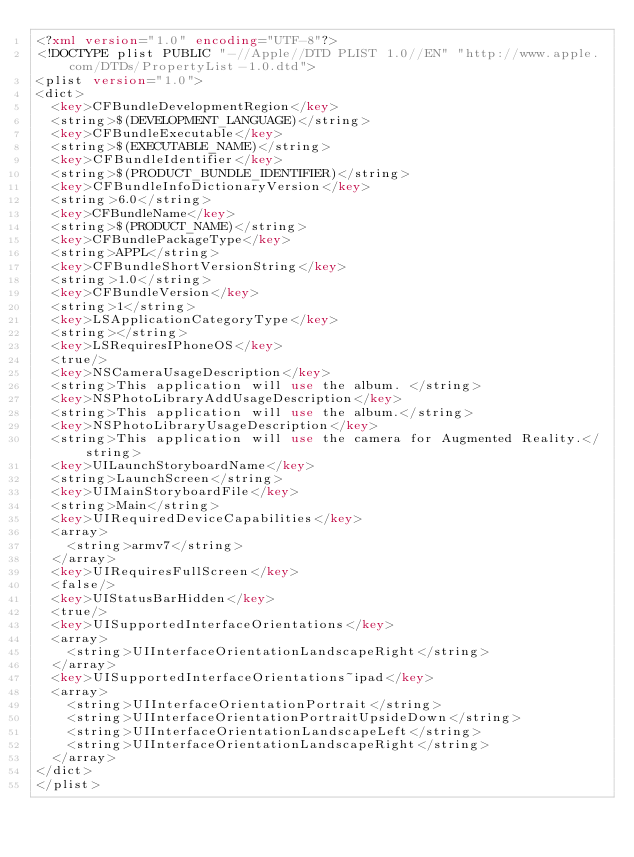<code> <loc_0><loc_0><loc_500><loc_500><_XML_><?xml version="1.0" encoding="UTF-8"?>
<!DOCTYPE plist PUBLIC "-//Apple//DTD PLIST 1.0//EN" "http://www.apple.com/DTDs/PropertyList-1.0.dtd">
<plist version="1.0">
<dict>
	<key>CFBundleDevelopmentRegion</key>
	<string>$(DEVELOPMENT_LANGUAGE)</string>
	<key>CFBundleExecutable</key>
	<string>$(EXECUTABLE_NAME)</string>
	<key>CFBundleIdentifier</key>
	<string>$(PRODUCT_BUNDLE_IDENTIFIER)</string>
	<key>CFBundleInfoDictionaryVersion</key>
	<string>6.0</string>
	<key>CFBundleName</key>
	<string>$(PRODUCT_NAME)</string>
	<key>CFBundlePackageType</key>
	<string>APPL</string>
	<key>CFBundleShortVersionString</key>
	<string>1.0</string>
	<key>CFBundleVersion</key>
	<string>1</string>
	<key>LSApplicationCategoryType</key>
	<string></string>
	<key>LSRequiresIPhoneOS</key>
	<true/>
	<key>NSCameraUsageDescription</key>
	<string>This application will use the album. </string>
	<key>NSPhotoLibraryAddUsageDescription</key>
	<string>This application will use the album.</string>
	<key>NSPhotoLibraryUsageDescription</key>
	<string>This application will use the camera for Augmented Reality.</string>
	<key>UILaunchStoryboardName</key>
	<string>LaunchScreen</string>
	<key>UIMainStoryboardFile</key>
	<string>Main</string>
	<key>UIRequiredDeviceCapabilities</key>
	<array>
		<string>armv7</string>
	</array>
	<key>UIRequiresFullScreen</key>
	<false/>
	<key>UIStatusBarHidden</key>
	<true/>
	<key>UISupportedInterfaceOrientations</key>
	<array>
		<string>UIInterfaceOrientationLandscapeRight</string>
	</array>
	<key>UISupportedInterfaceOrientations~ipad</key>
	<array>
		<string>UIInterfaceOrientationPortrait</string>
		<string>UIInterfaceOrientationPortraitUpsideDown</string>
		<string>UIInterfaceOrientationLandscapeLeft</string>
		<string>UIInterfaceOrientationLandscapeRight</string>
	</array>
</dict>
</plist>
</code> 